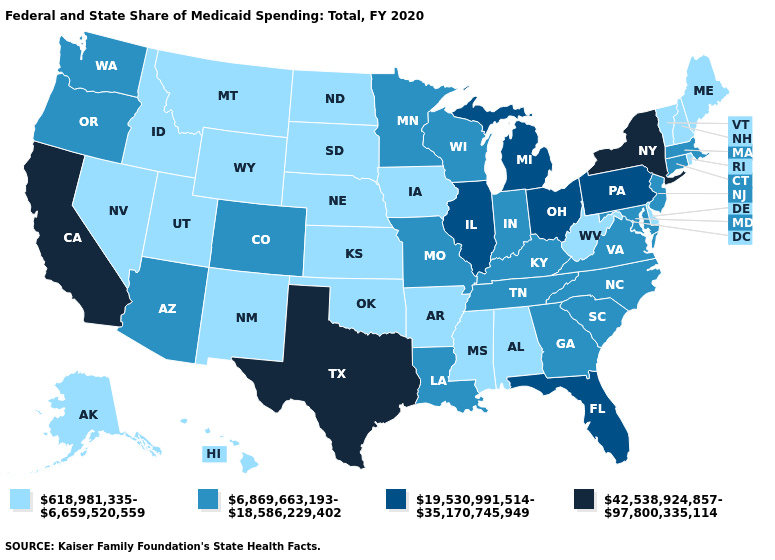What is the value of Minnesota?
Concise answer only. 6,869,663,193-18,586,229,402. What is the lowest value in the MidWest?
Concise answer only. 618,981,335-6,659,520,559. Name the states that have a value in the range 6,869,663,193-18,586,229,402?
Quick response, please. Arizona, Colorado, Connecticut, Georgia, Indiana, Kentucky, Louisiana, Maryland, Massachusetts, Minnesota, Missouri, New Jersey, North Carolina, Oregon, South Carolina, Tennessee, Virginia, Washington, Wisconsin. Among the states that border Georgia , does Florida have the lowest value?
Short answer required. No. What is the value of California?
Quick response, please. 42,538,924,857-97,800,335,114. Is the legend a continuous bar?
Keep it brief. No. Name the states that have a value in the range 42,538,924,857-97,800,335,114?
Write a very short answer. California, New York, Texas. Does the map have missing data?
Short answer required. No. What is the value of Texas?
Answer briefly. 42,538,924,857-97,800,335,114. What is the value of Maryland?
Keep it brief. 6,869,663,193-18,586,229,402. Does Delaware have the same value as Georgia?
Be succinct. No. Which states have the highest value in the USA?
Keep it brief. California, New York, Texas. Does Vermont have the lowest value in the USA?
Give a very brief answer. Yes. What is the value of North Carolina?
Be succinct. 6,869,663,193-18,586,229,402. Does Texas have the highest value in the USA?
Short answer required. Yes. 